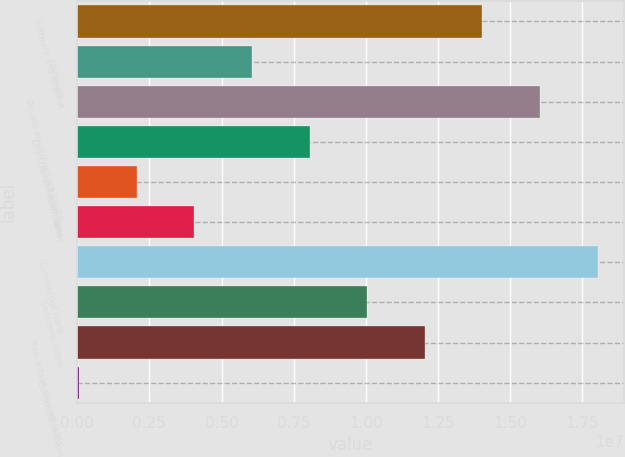Convert chart. <chart><loc_0><loc_0><loc_500><loc_500><bar_chart><fcel>Software and internet<fcel>Hardware<fcel>Private equity/venture capital<fcel>Life science/healthcare<fcel>Premium wine<fcel>Other<fcel>Commercial loans<fcel>Consumer loans<fcel>Real estate secured loans<fcel>Construction loans<nl><fcel>1.40368e+07<fcel>6.05287e+06<fcel>1.60327e+07<fcel>8.04884e+06<fcel>2.06093e+06<fcel>4.0569e+06<fcel>1.80287e+07<fcel>1.00448e+07<fcel>1.20408e+07<fcel>64957<nl></chart> 